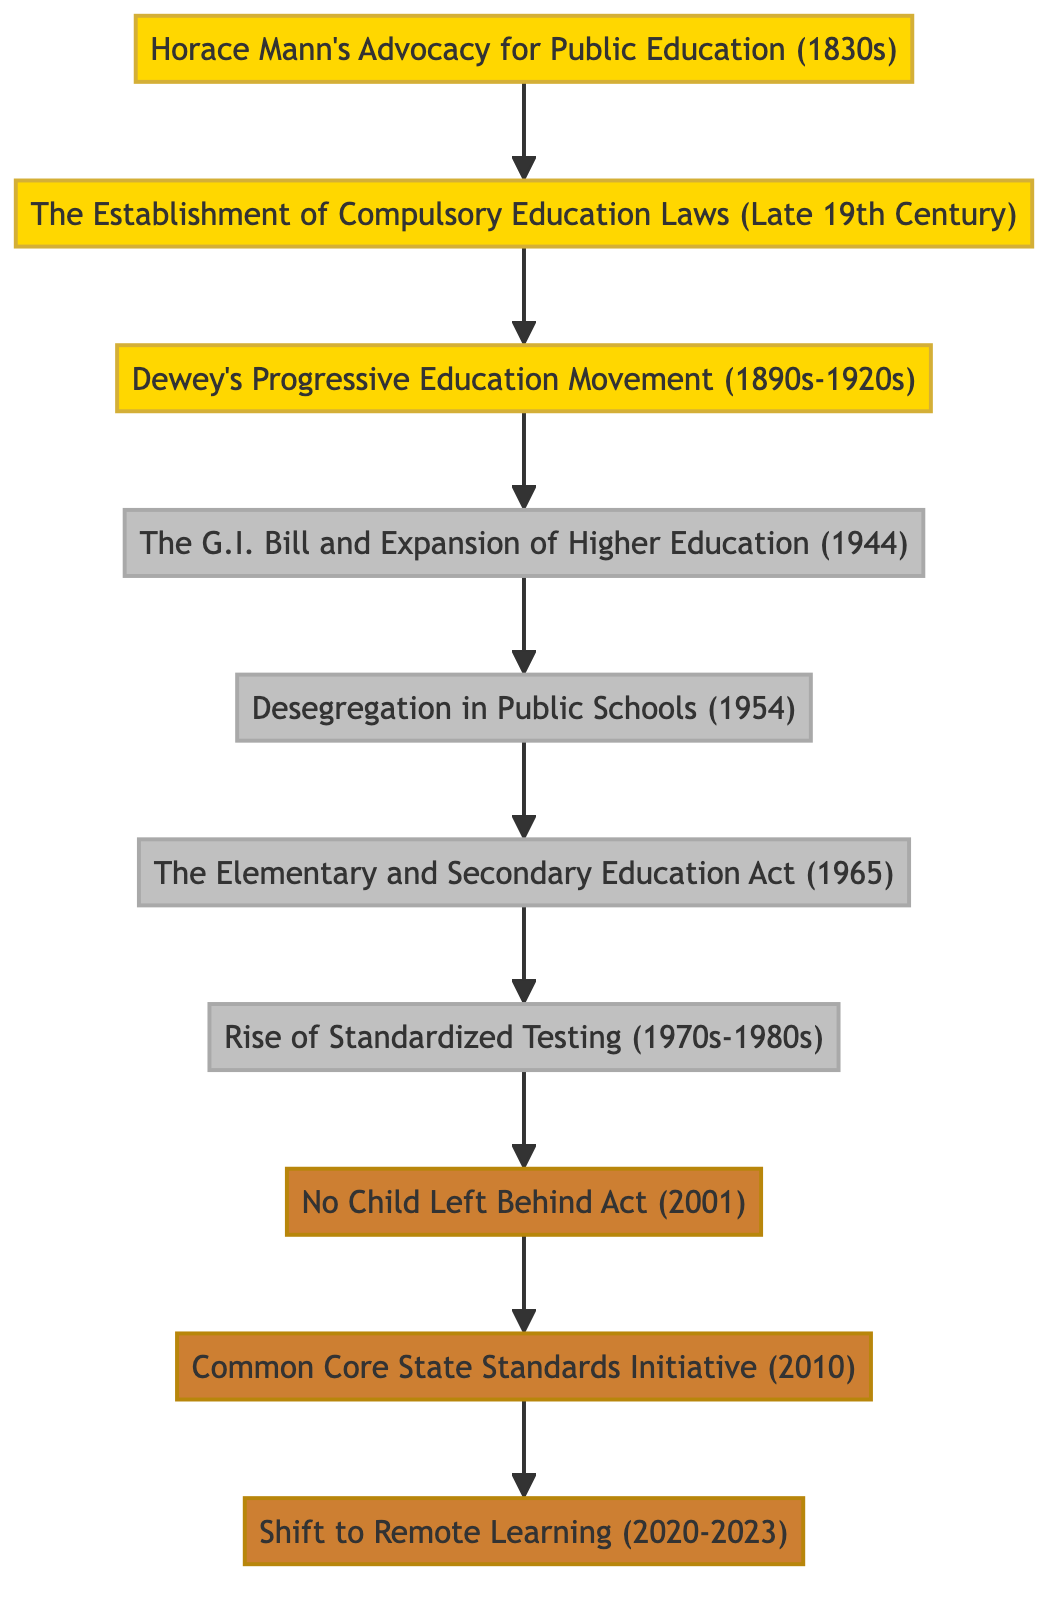What is the earliest educational reform mentioned in the diagram? The diagram starts with "Horace Mann's Advocacy for Public Education (1830s)," which is identified as the first node in the directed graph.
Answer: Horace Mann's Advocacy for Public Education (1830s) How many nodes are there in the diagram? The diagram lists a total of 10 distinct elements that represent educational reforms, each identified as a node.
Answer: 10 What is the last reform listed in the diagram? Following the arrows from node connections, the last node in the sequence is "Shift to Remote Learning (2020-2023)."
Answer: Shift to Remote Learning (2020-2023) Which reform directly follows "Desegregation in Public Schools (1954)"? By tracing the directed edge from the node "Desegregation in Public Schools (1954)," the next node connected is "The Elementary and Secondary Education Act (1965)."
Answer: The Elementary and Secondary Education Act (1965) Which two reforms are separated by the "Rise of Standardized Testing (1970s-1980s)"? Looking at the connections, "The Elementary and Secondary Education Act (1965)" leads into "Rise of Standardized Testing (1970s-1980s)," which in turn connects to "No Child Left Behind Act (2001)," indicating that these two reforms are separated by the node defining standardized testing.
Answer: The Elementary and Secondary Education Act (1965) and No Child Left Behind Act (2001) What do the nodes from "Horace Mann's Advocacy for Public Education (1830s)" to "Dewey's Progressive Education Movement (1890s-1920s)" signify? The flow from the first to the third node suggests a timeline of progression, representing the evolution of thought and policy in education from Mann to Dewey's movement.
Answer: Progression of educational thought How many edges (connections) are in the diagram? By counting how many links connect the nodes, there are a total of 9 edges that depict relationships between the various reforms.
Answer: 9 What is the significance of the "No Child Left Behind Act (2001)" in the timeline? This act is identified as a pivotal reform within the context of the diagram, following "Rise of Standardized Testing (1970s-1980s)," indicating a culmination of prior standards and assessments in education reform.
Answer: Pivotal reform for standardized education How does the diagram categorize the educational reforms into eras? The diagram uses color coding (yellow, gray, bronze) to visually differentiate three distinct eras of educational reforms, providing a historical context to the developments.
Answer: By color coding into eras 